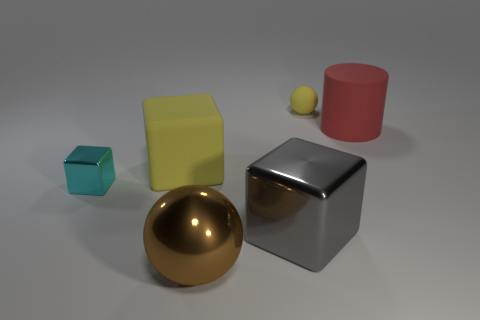Subtract all small metal blocks. How many blocks are left? 2 Add 1 big rubber objects. How many objects exist? 7 Subtract all cyan cubes. How many cubes are left? 2 Subtract 1 cubes. How many cubes are left? 2 Subtract all gray spheres. Subtract all brown cylinders. How many spheres are left? 2 Subtract all yellow cubes. How many yellow balls are left? 1 Subtract all big purple metal spheres. Subtract all metallic blocks. How many objects are left? 4 Add 2 big gray metal blocks. How many big gray metal blocks are left? 3 Add 3 small matte things. How many small matte things exist? 4 Subtract 0 brown cylinders. How many objects are left? 6 